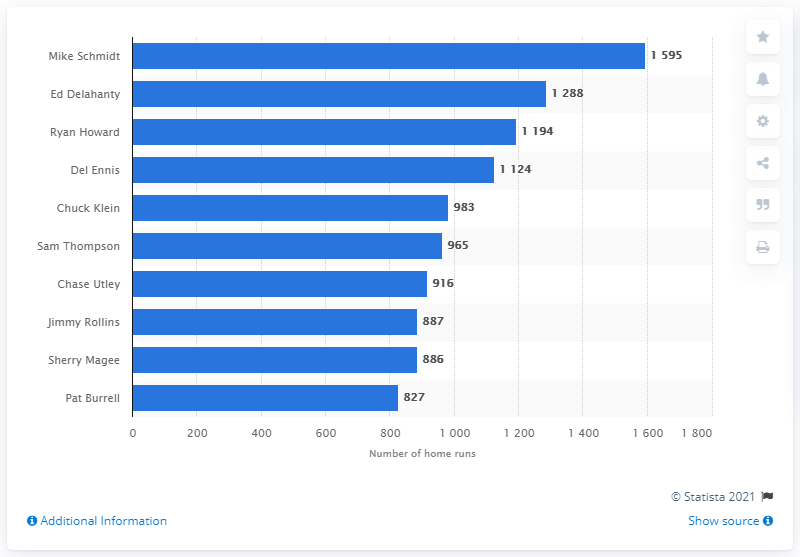Identify some key points in this picture. Mike Schmidt holds the record for the most RBI in franchise history. 